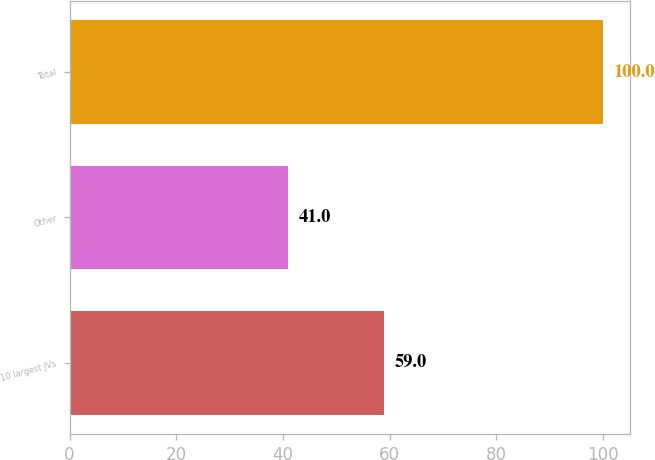Convert chart. <chart><loc_0><loc_0><loc_500><loc_500><bar_chart><fcel>10 largest JVs<fcel>Other<fcel>Total<nl><fcel>59<fcel>41<fcel>100<nl></chart> 